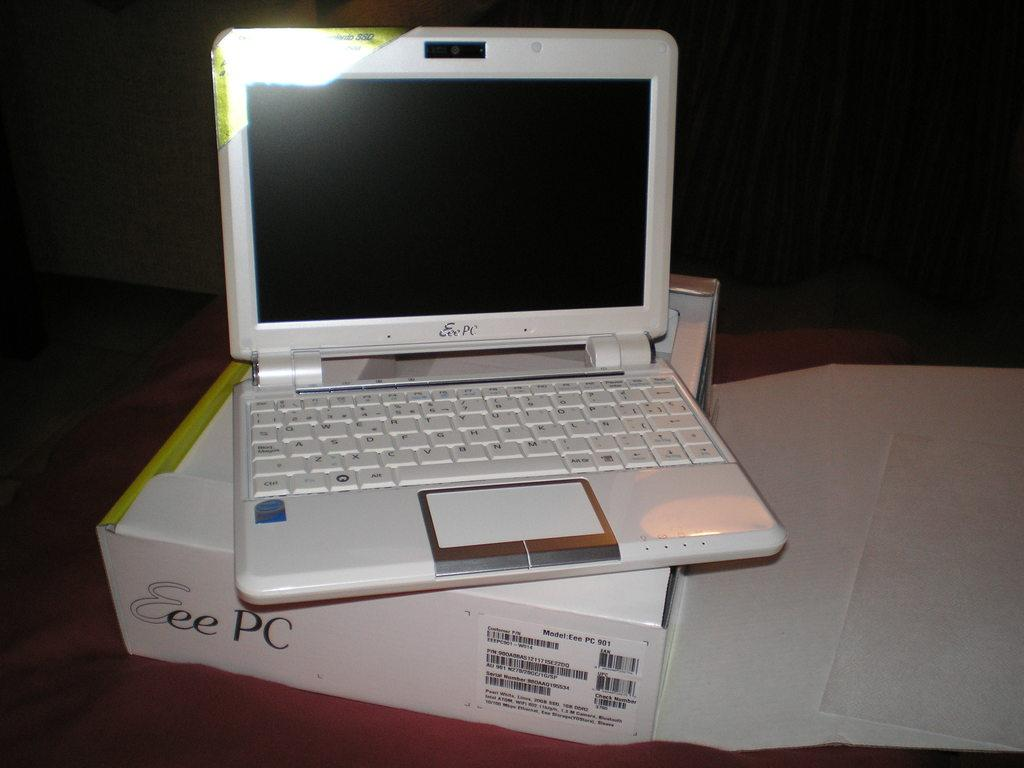What electronic device is visible in the image? There is a laptop in the image. Where is the laptop placed? The laptop is present on a box. What is the box resting on? The box is on a table. What type of fowl is sitting on the laptop in the image? There is no fowl present in the image; the laptop is on a box. 